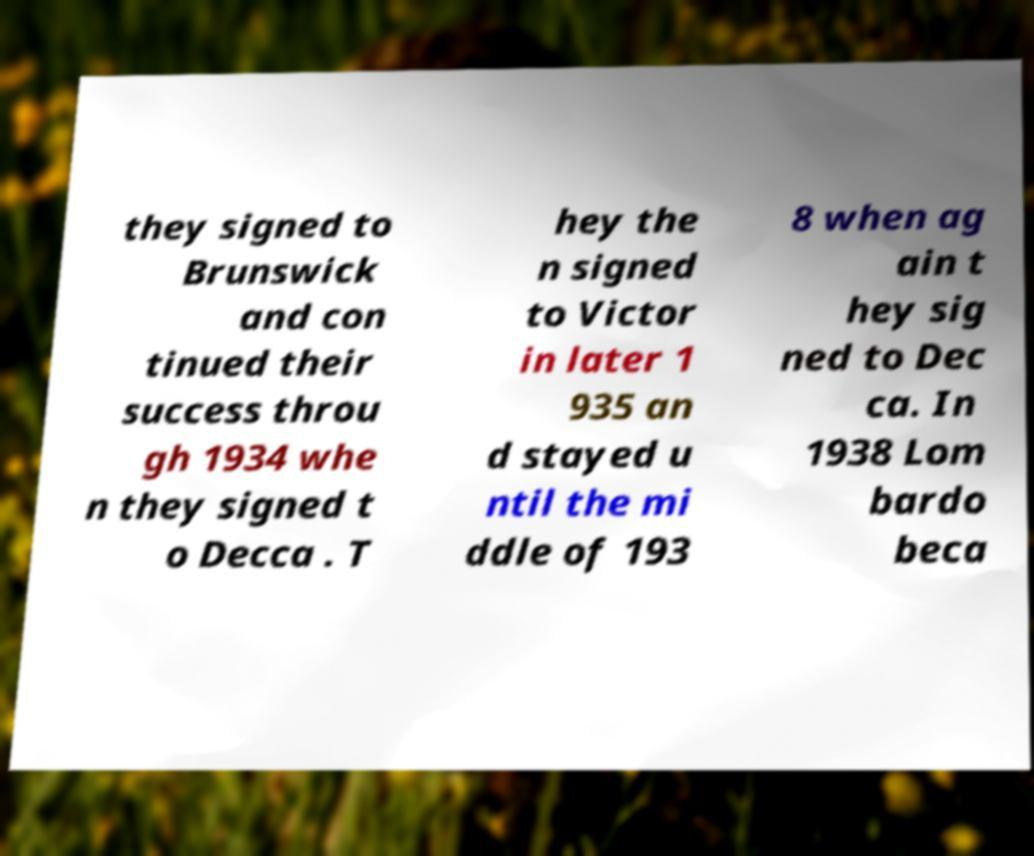For documentation purposes, I need the text within this image transcribed. Could you provide that? they signed to Brunswick and con tinued their success throu gh 1934 whe n they signed t o Decca . T hey the n signed to Victor in later 1 935 an d stayed u ntil the mi ddle of 193 8 when ag ain t hey sig ned to Dec ca. In 1938 Lom bardo beca 